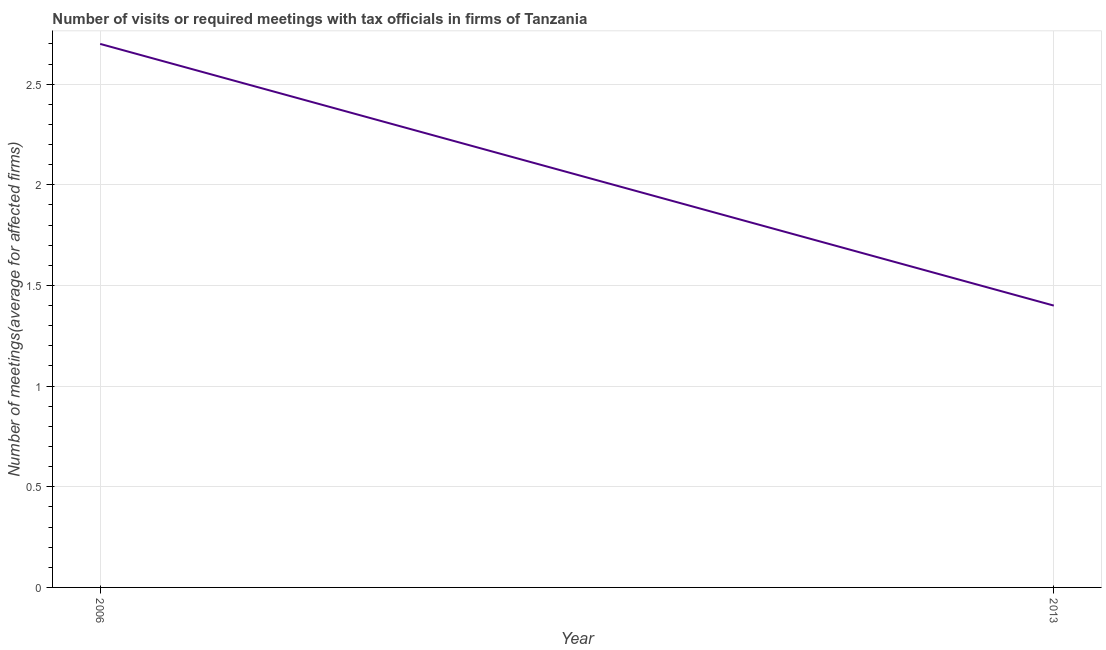In which year was the number of required meetings with tax officials minimum?
Give a very brief answer. 2013. What is the difference between the number of required meetings with tax officials in 2006 and 2013?
Ensure brevity in your answer.  1.3. What is the average number of required meetings with tax officials per year?
Make the answer very short. 2.05. What is the median number of required meetings with tax officials?
Make the answer very short. 2.05. What is the ratio of the number of required meetings with tax officials in 2006 to that in 2013?
Ensure brevity in your answer.  1.93. Does the number of required meetings with tax officials monotonically increase over the years?
Offer a terse response. No. How many years are there in the graph?
Your answer should be compact. 2. Are the values on the major ticks of Y-axis written in scientific E-notation?
Your answer should be very brief. No. Does the graph contain any zero values?
Offer a terse response. No. Does the graph contain grids?
Offer a terse response. Yes. What is the title of the graph?
Your response must be concise. Number of visits or required meetings with tax officials in firms of Tanzania. What is the label or title of the X-axis?
Your response must be concise. Year. What is the label or title of the Y-axis?
Your answer should be compact. Number of meetings(average for affected firms). What is the Number of meetings(average for affected firms) in 2013?
Your response must be concise. 1.4. What is the ratio of the Number of meetings(average for affected firms) in 2006 to that in 2013?
Make the answer very short. 1.93. 